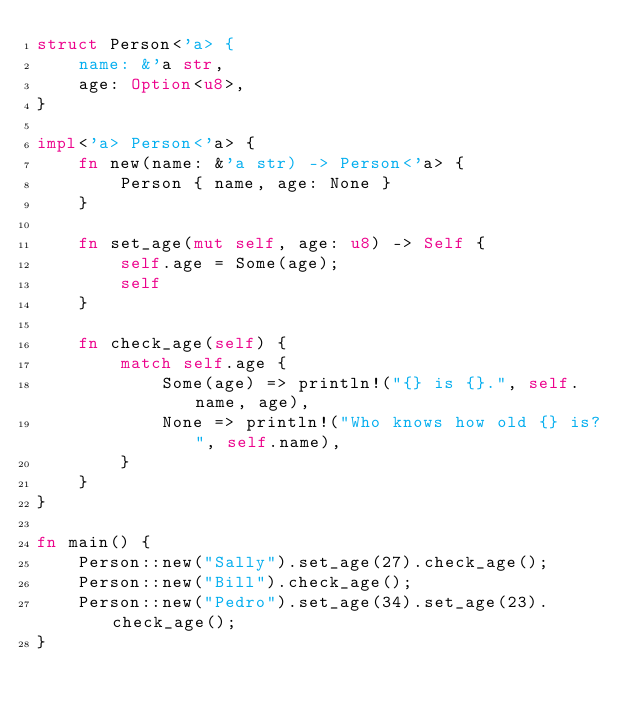Convert code to text. <code><loc_0><loc_0><loc_500><loc_500><_Rust_>struct Person<'a> {
    name: &'a str,
    age: Option<u8>,
}

impl<'a> Person<'a> {
    fn new(name: &'a str) -> Person<'a> {
        Person { name, age: None }
    }

    fn set_age(mut self, age: u8) -> Self {
        self.age = Some(age);
        self
    }

    fn check_age(self) {
        match self.age {
            Some(age) => println!("{} is {}.", self.name, age),
            None => println!("Who knows how old {} is?", self.name),
        }
    }
}

fn main() {
    Person::new("Sally").set_age(27).check_age();
    Person::new("Bill").check_age();
    Person::new("Pedro").set_age(34).set_age(23).check_age();
}
</code> 